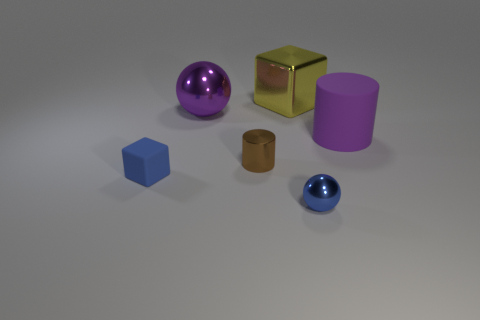Add 2 purple matte objects. How many objects exist? 8 Subtract all cylinders. How many objects are left? 4 Add 3 rubber cylinders. How many rubber cylinders exist? 4 Subtract 0 gray cubes. How many objects are left? 6 Subtract all big yellow cylinders. Subtract all large purple metal objects. How many objects are left? 5 Add 6 small brown shiny things. How many small brown shiny things are left? 7 